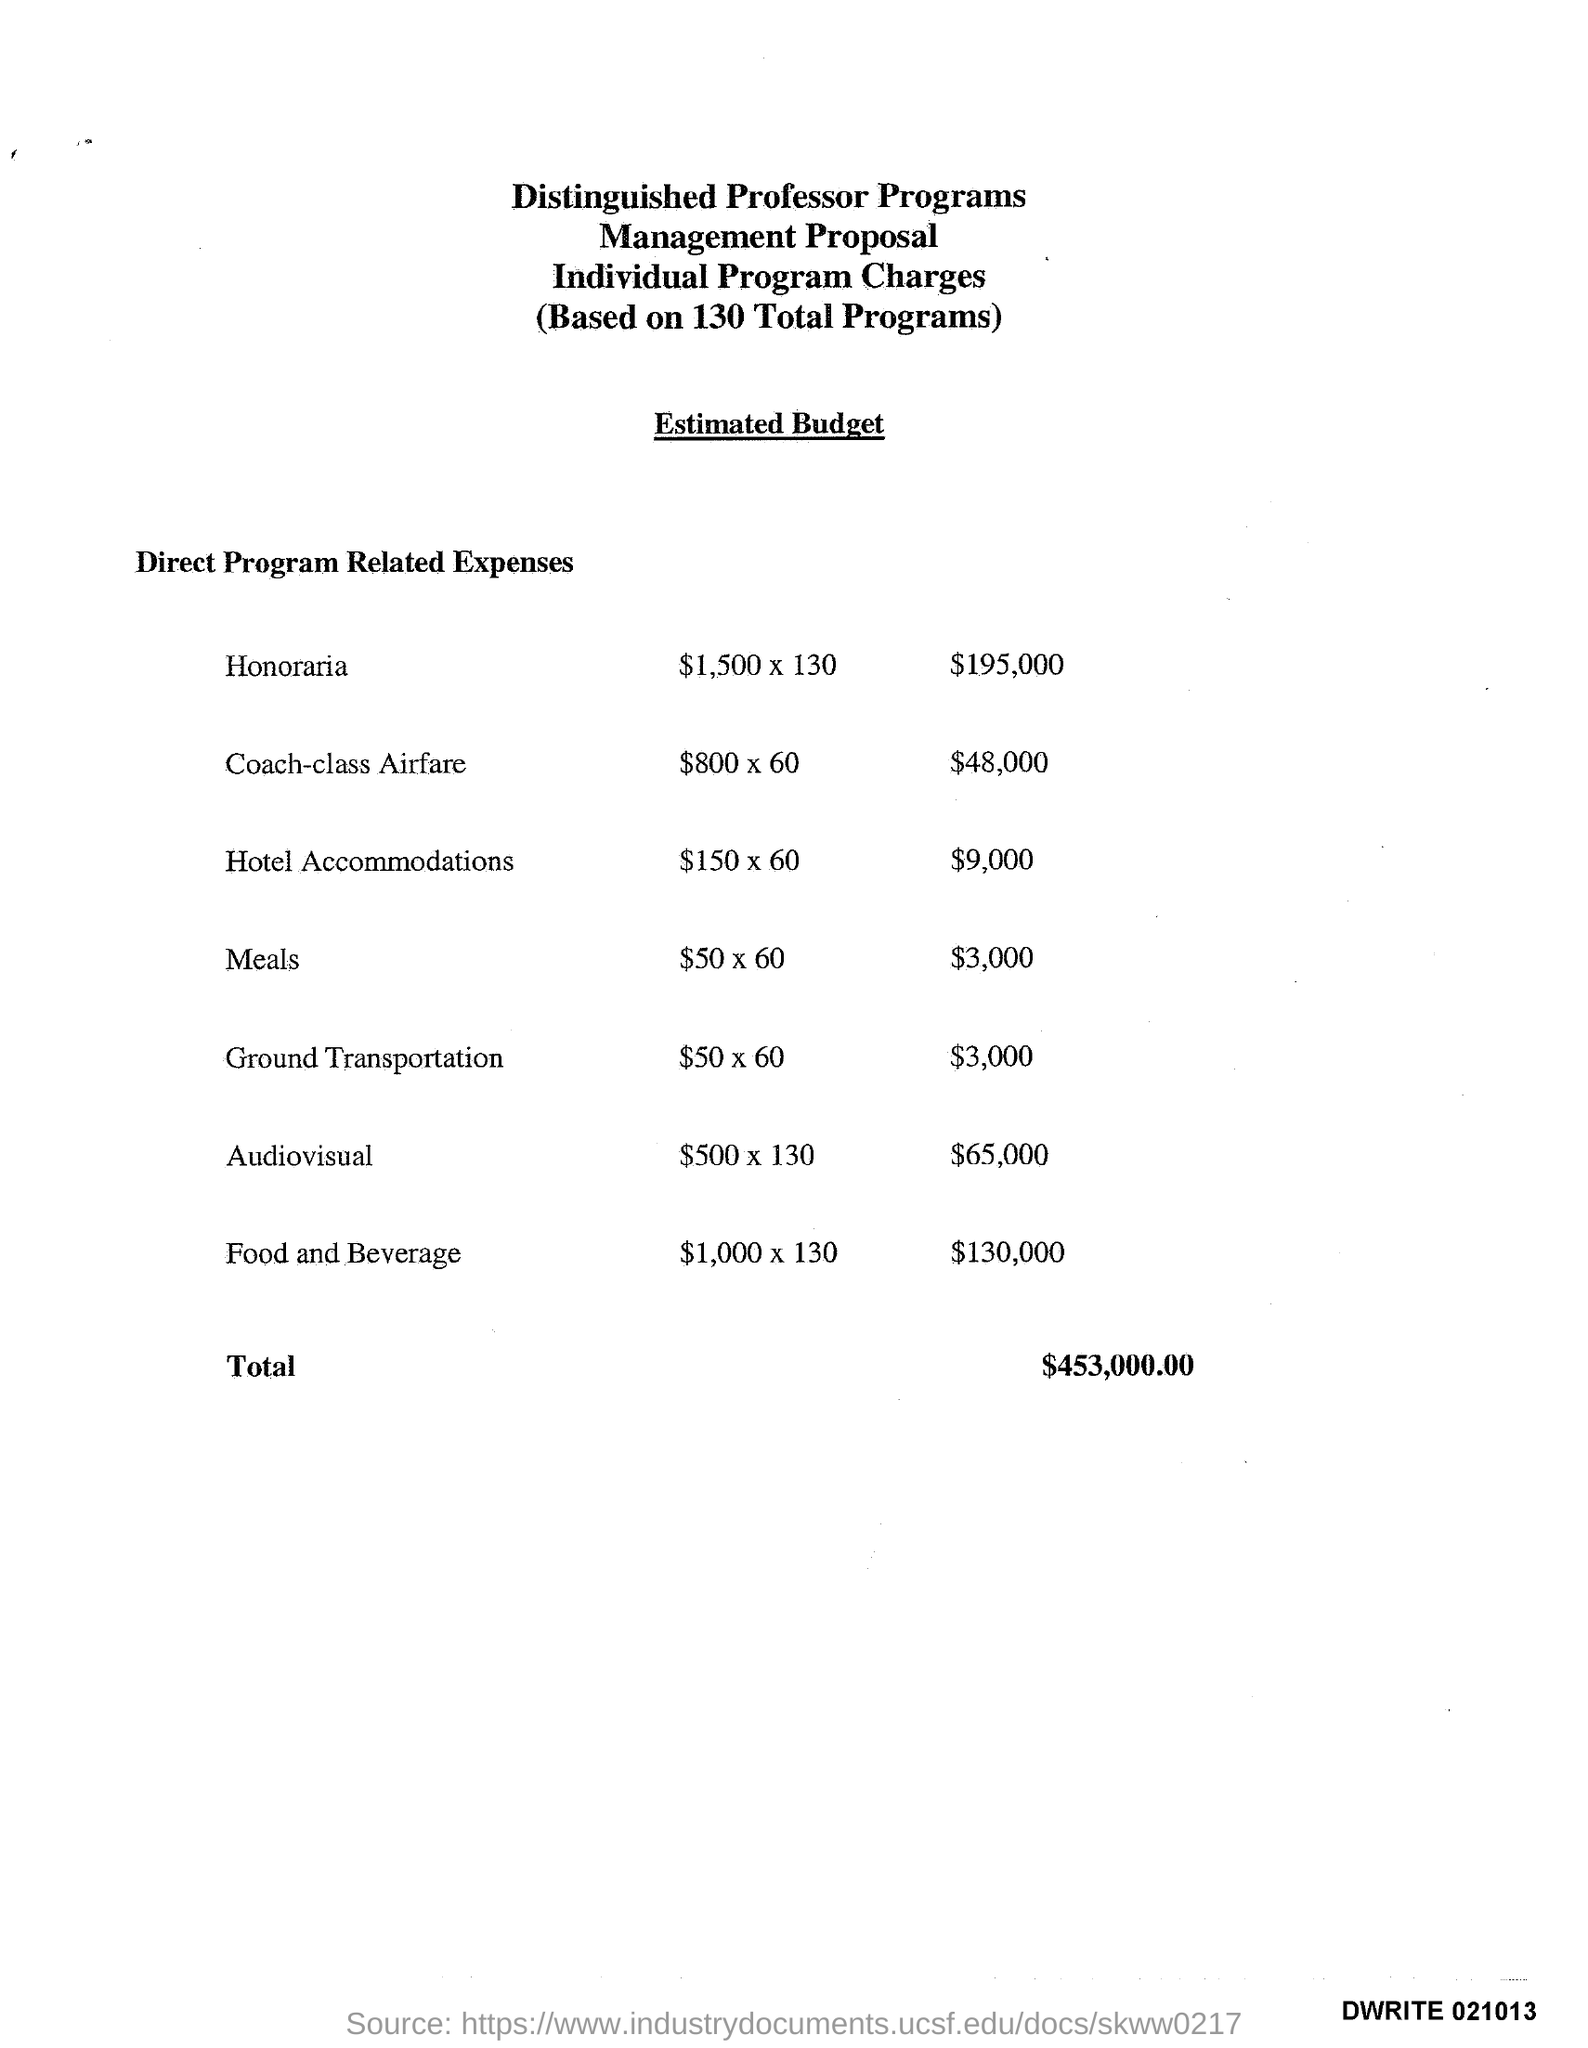What is the least amount of expenses ?
Provide a succinct answer. $3,000. What is the total amount of expenses ?
Ensure brevity in your answer.  $453,000.00. What is the name of the program which spent $195,000 ?
Give a very brief answer. Honoraria. 